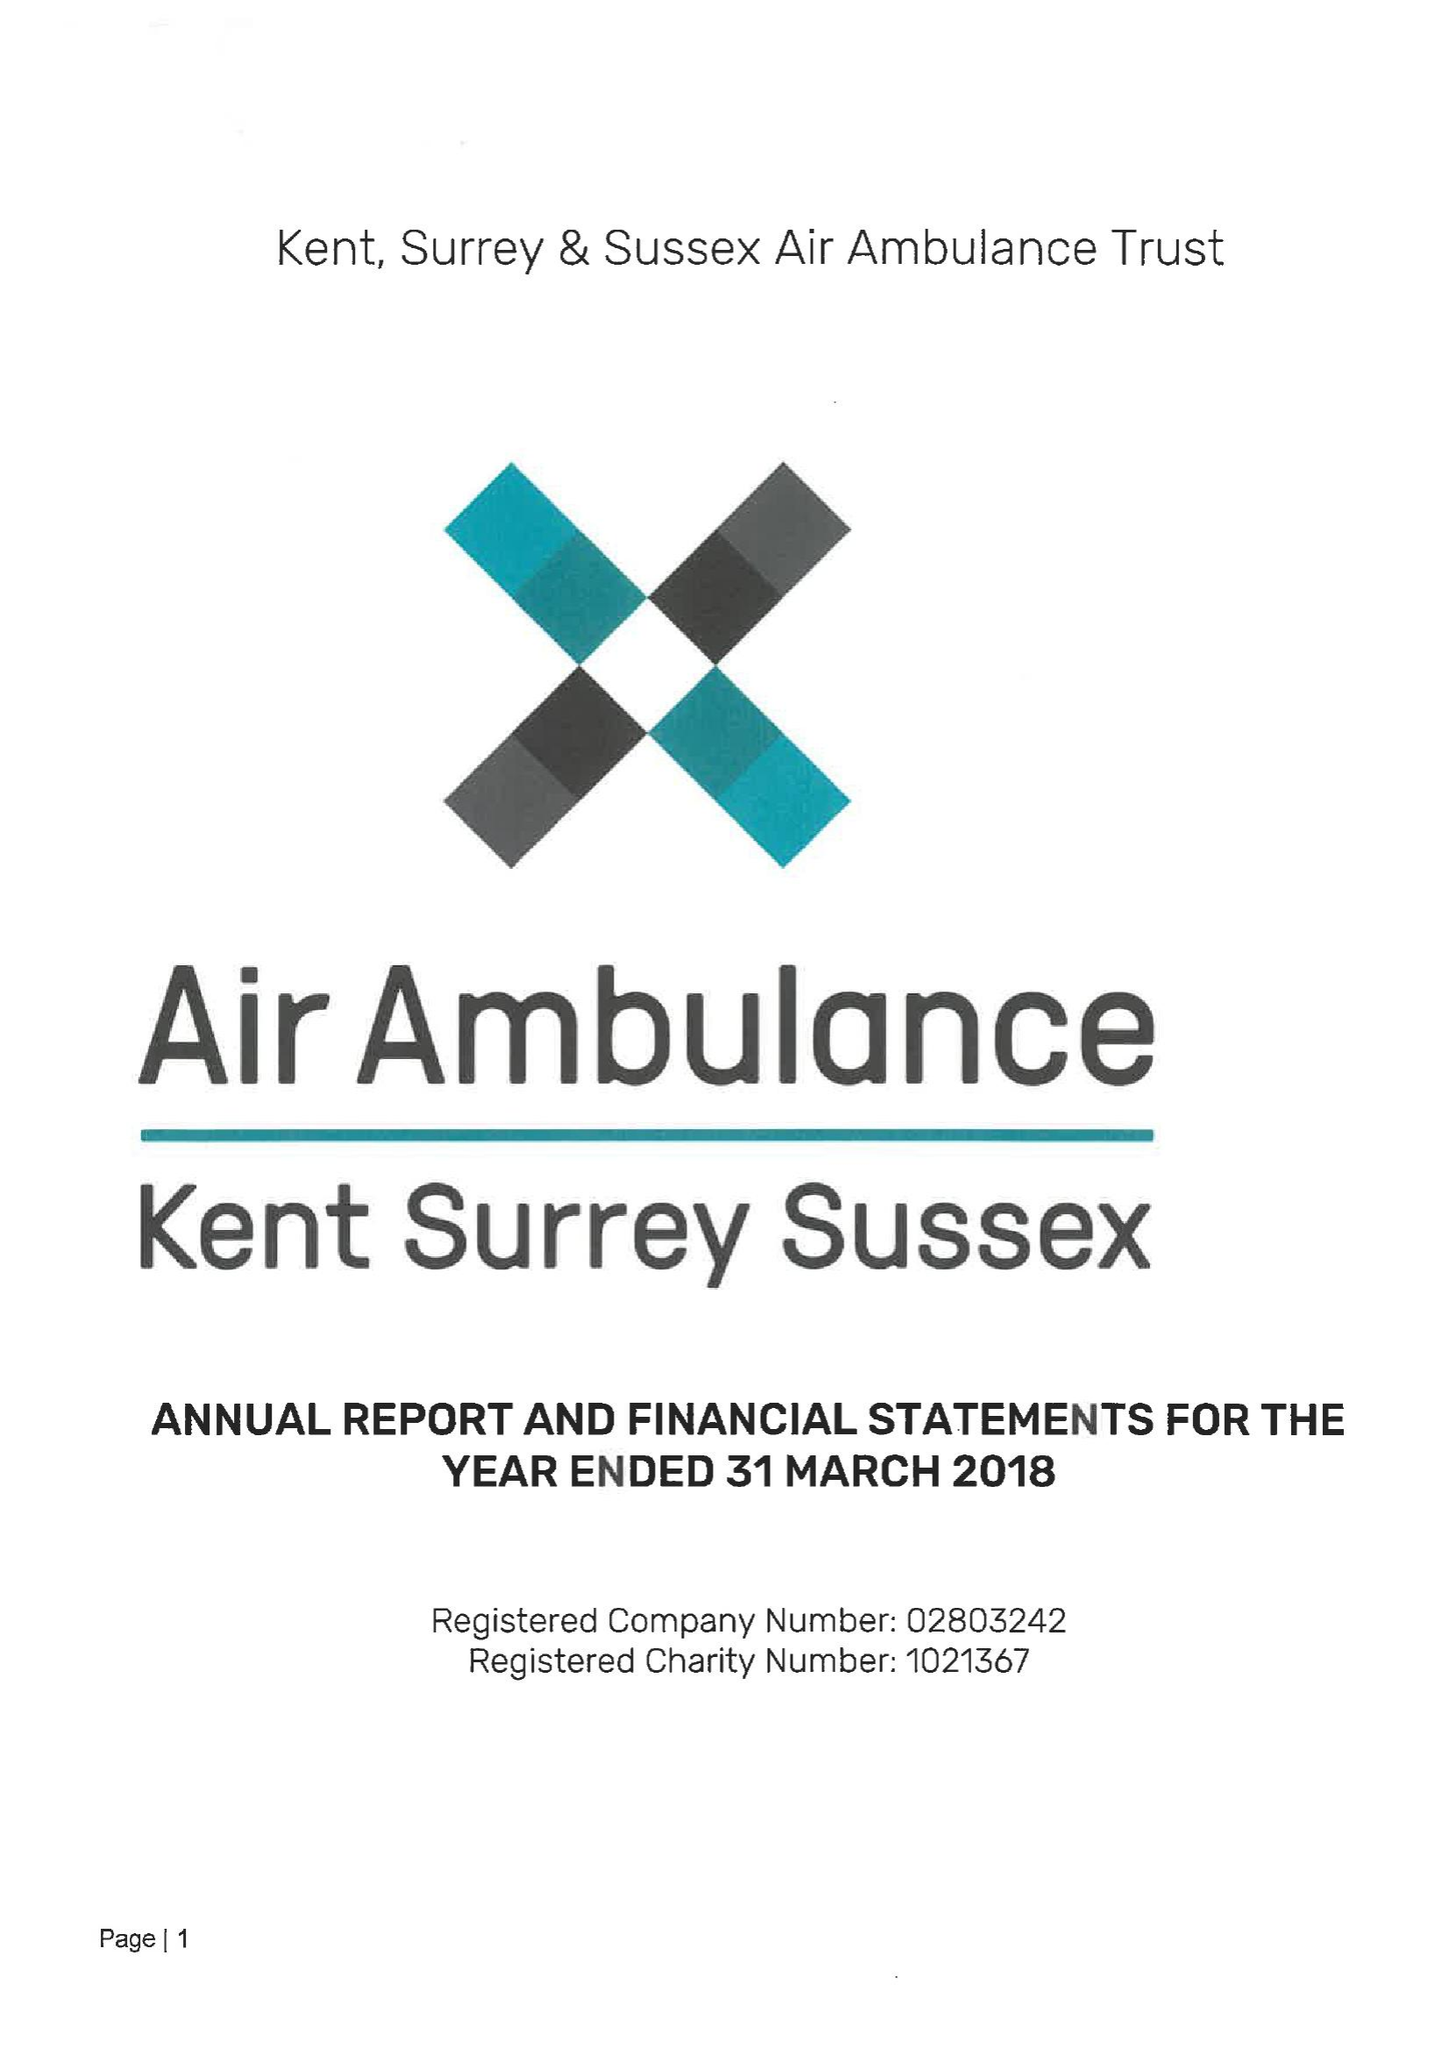What is the value for the address__street_line?
Answer the question using a single word or phrase. MAIDSTONE ROAD 